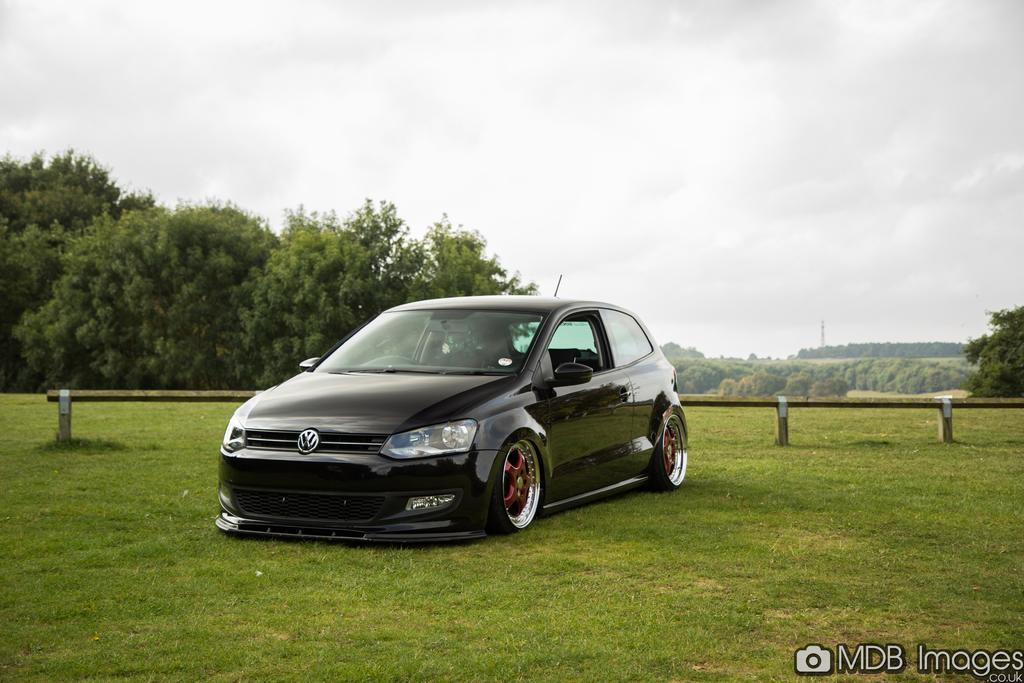What is located on the ground in the image? There is a car on the ground in the image. What can be seen in the background of the image? There are trees in the background of the image. What is visible at the top of the image? The sky is visible at the top of the image. What type of barrier is behind the car in the image? There is a wooden fence behind the car in the image. What type of attraction is the goat performing in the image? There is no goat present in the image, so it is not possible to answer that question. 